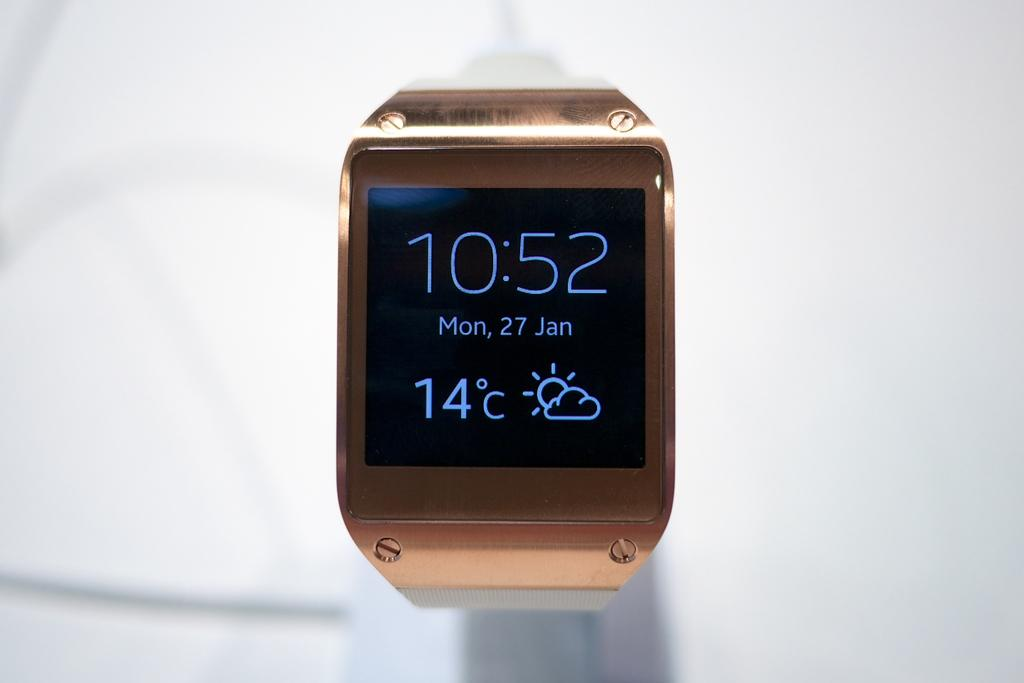<image>
Offer a succinct explanation of the picture presented. The time for Monday, January 27 is 10:52. 